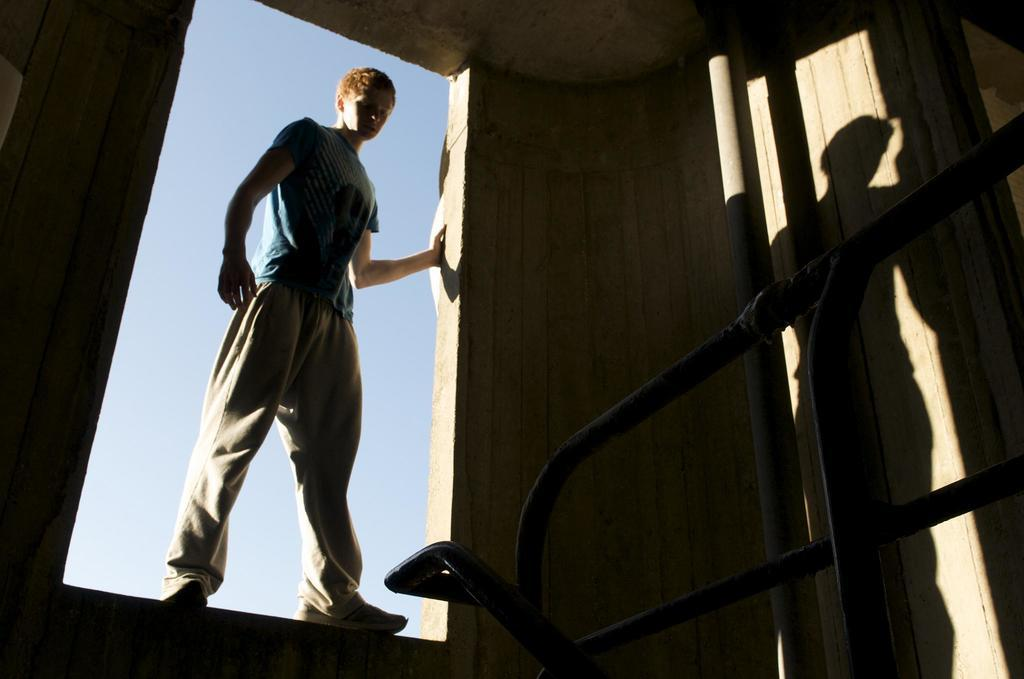Who or what is present in the image? There is a person in the image. What is the person standing near or in front of? There is a wall in the image. What else can be seen in the image besides the person and the wall? There is a pole in the image. What can be seen in the background of the image? The sky is visible in the background of the image. How many copies of the person's hand can be seen in the image? There is no mention of copies or hands in the image; only a person, wall, pole, and sky are present. 